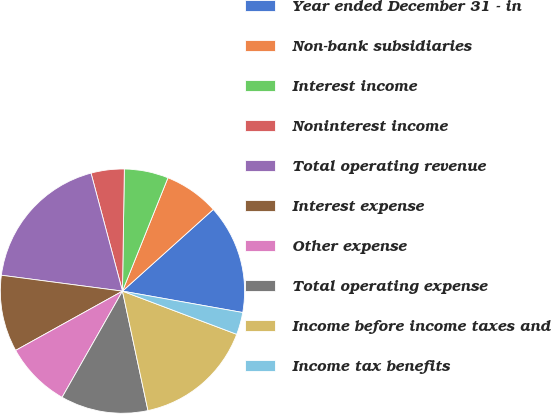Convert chart to OTSL. <chart><loc_0><loc_0><loc_500><loc_500><pie_chart><fcel>Year ended December 31 - in<fcel>Non-bank subsidiaries<fcel>Interest income<fcel>Noninterest income<fcel>Total operating revenue<fcel>Interest expense<fcel>Other expense<fcel>Total operating expense<fcel>Income before income taxes and<fcel>Income tax benefits<nl><fcel>14.46%<fcel>7.27%<fcel>5.83%<fcel>4.39%<fcel>18.78%<fcel>10.14%<fcel>8.71%<fcel>11.58%<fcel>15.9%<fcel>2.95%<nl></chart> 